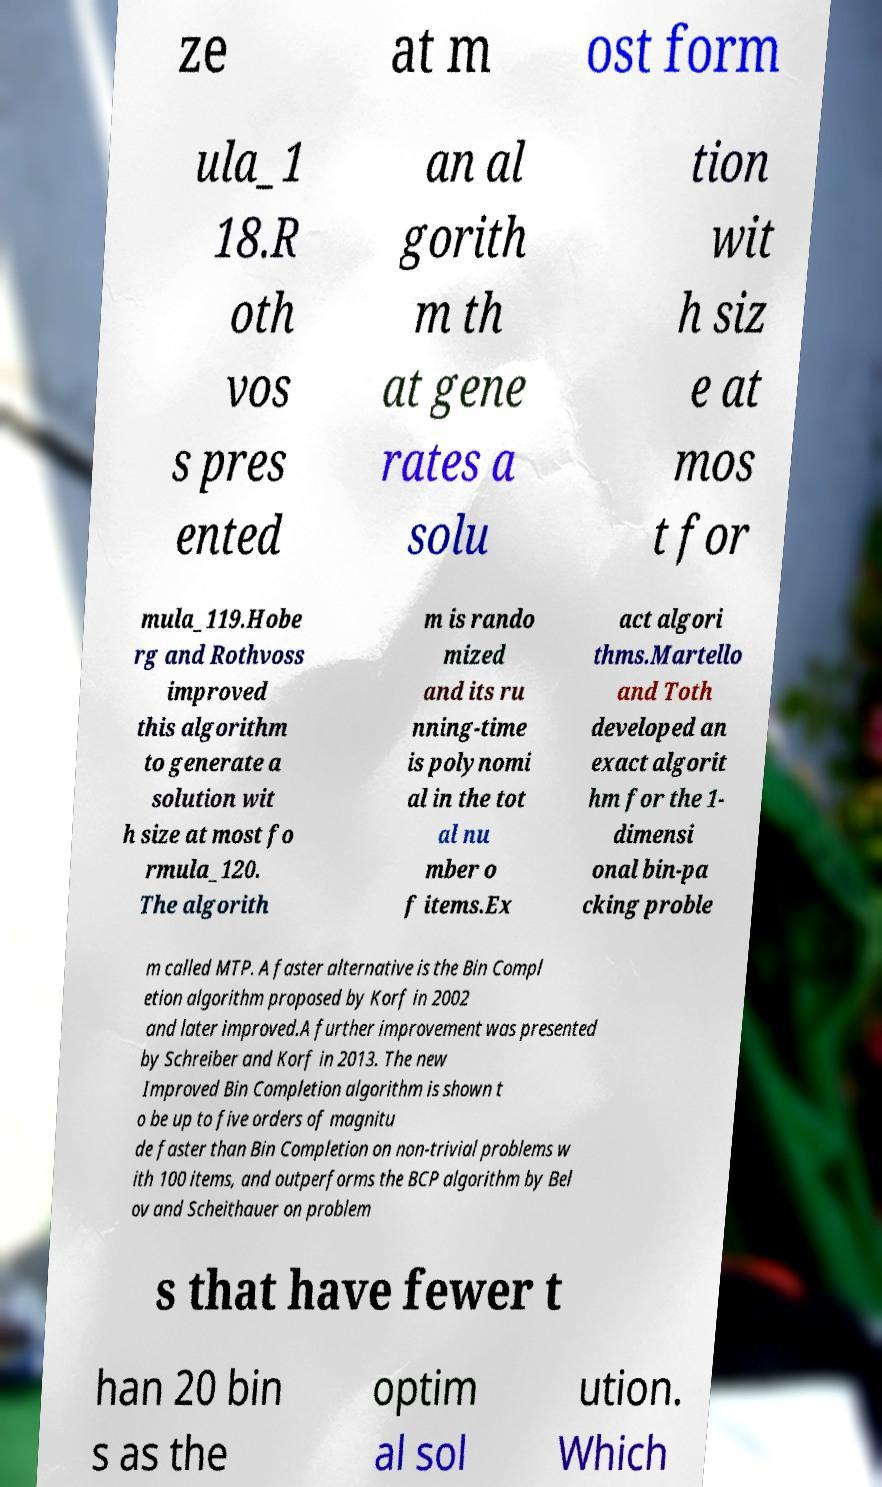What messages or text are displayed in this image? I need them in a readable, typed format. ze at m ost form ula_1 18.R oth vos s pres ented an al gorith m th at gene rates a solu tion wit h siz e at mos t for mula_119.Hobe rg and Rothvoss improved this algorithm to generate a solution wit h size at most fo rmula_120. The algorith m is rando mized and its ru nning-time is polynomi al in the tot al nu mber o f items.Ex act algori thms.Martello and Toth developed an exact algorit hm for the 1- dimensi onal bin-pa cking proble m called MTP. A faster alternative is the Bin Compl etion algorithm proposed by Korf in 2002 and later improved.A further improvement was presented by Schreiber and Korf in 2013. The new Improved Bin Completion algorithm is shown t o be up to five orders of magnitu de faster than Bin Completion on non-trivial problems w ith 100 items, and outperforms the BCP algorithm by Bel ov and Scheithauer on problem s that have fewer t han 20 bin s as the optim al sol ution. Which 